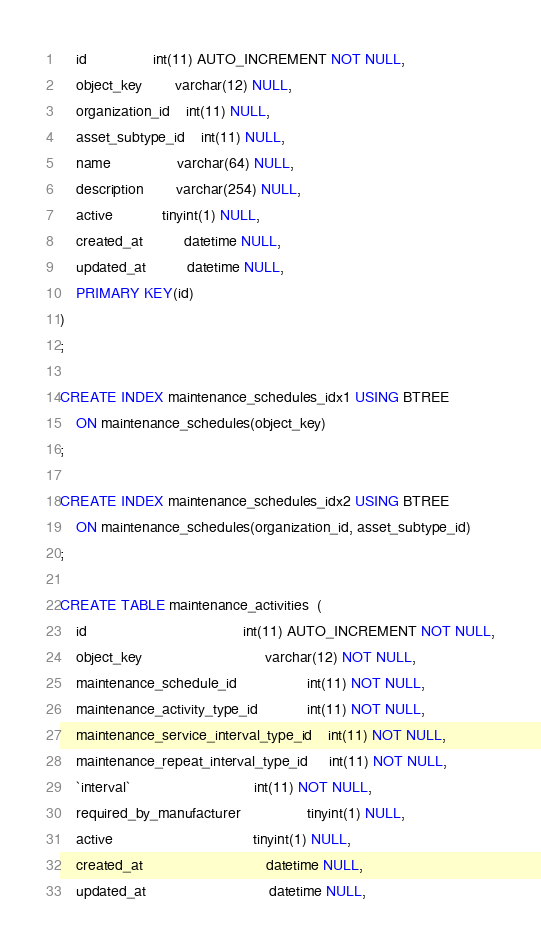Convert code to text. <code><loc_0><loc_0><loc_500><loc_500><_SQL_>	id              	int(11) AUTO_INCREMENT NOT NULL,
	object_key      	varchar(12) NULL,
	organization_id 	int(11) NULL,
	asset_subtype_id	int(11) NULL,
	name            	varchar(64) NULL,
	description     	varchar(254) NULL,
	active          	tinyint(1) NULL,
	created_at          datetime NULL,
	updated_at          datetime NULL,
	PRIMARY KEY(id)
)
;

CREATE INDEX maintenance_schedules_idx1 USING BTREE 
	ON maintenance_schedules(object_key)
;

CREATE INDEX maintenance_schedules_idx2 USING BTREE 
	ON maintenance_schedules(organization_id, asset_subtype_id)
;

CREATE TABLE maintenance_activities  ( 
	id                                      int(11) AUTO_INCREMENT NOT NULL,
	object_key                              varchar(12) NOT NULL,
	maintenance_schedule_id                 int(11) NOT NULL,
	maintenance_activity_type_id            int(11) NOT NULL,
	maintenance_service_interval_type_id    int(11) NOT NULL,
    maintenance_repeat_interval_type_id     int(11) NOT NULL,
    `interval`                              int(11) NOT NULL,
	required_by_manufacturer              	tinyint(1) NULL,
	active                                  tinyint(1) NULL,
	created_at                              datetime NULL,
	updated_at                              datetime NULL,</code> 